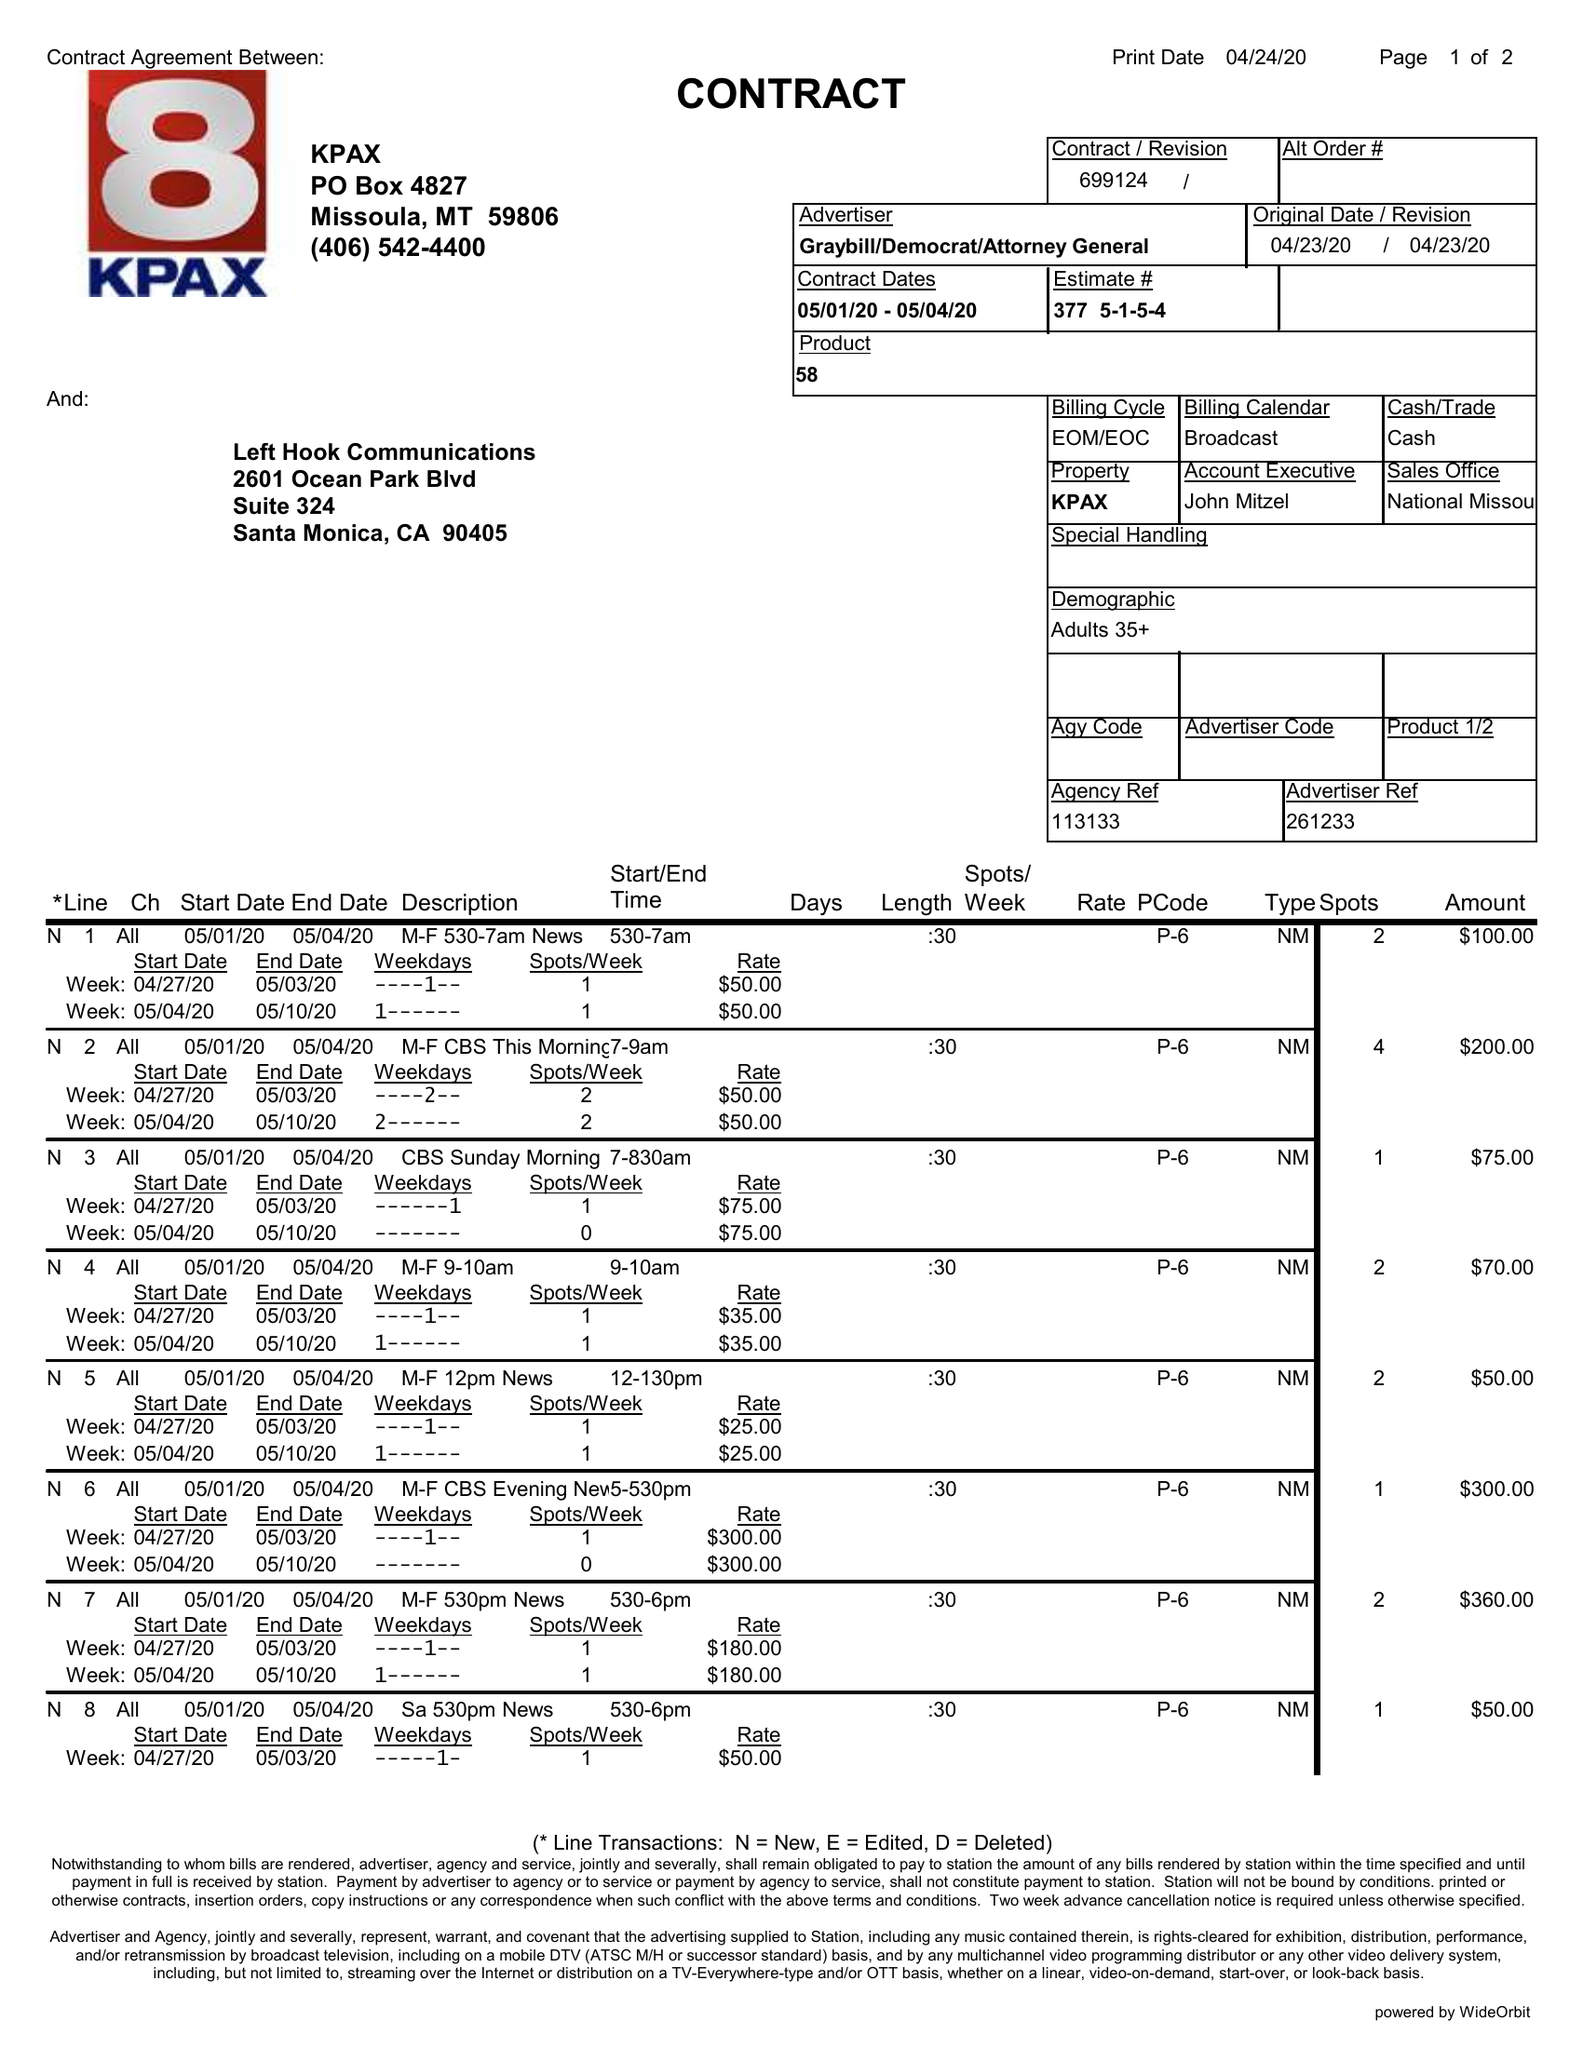What is the value for the flight_from?
Answer the question using a single word or phrase. 05/01/20 